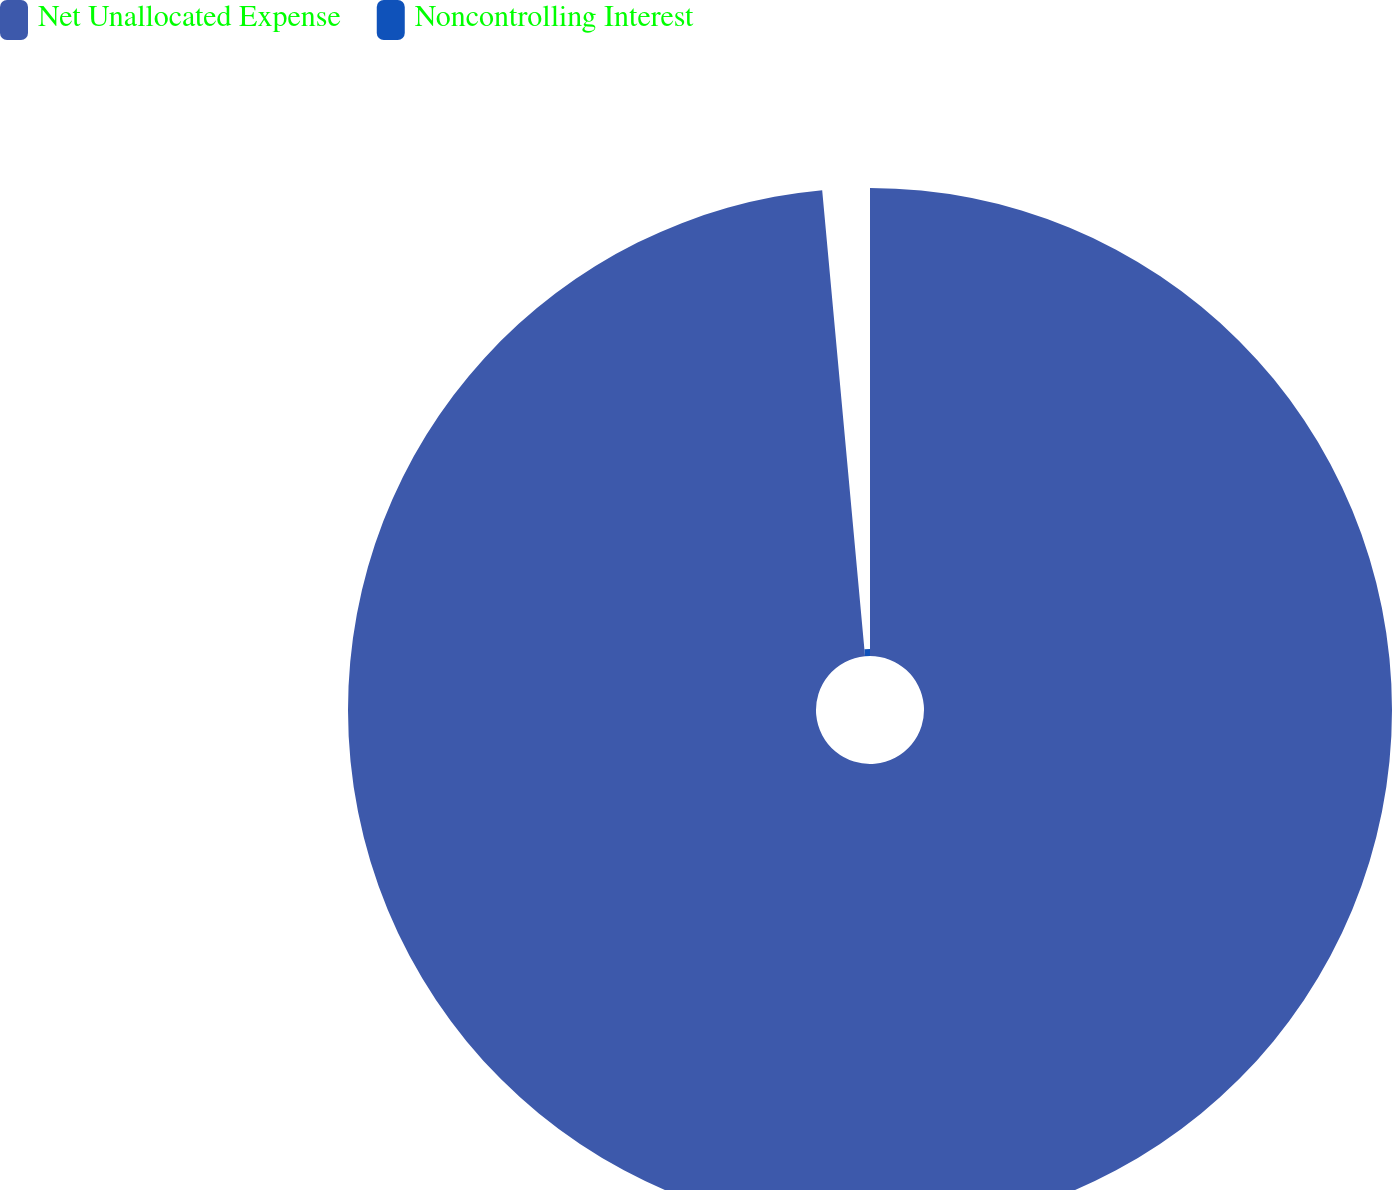Convert chart. <chart><loc_0><loc_0><loc_500><loc_500><pie_chart><fcel>Net Unallocated Expense<fcel>Noncontrolling Interest<nl><fcel>98.54%<fcel>1.46%<nl></chart> 